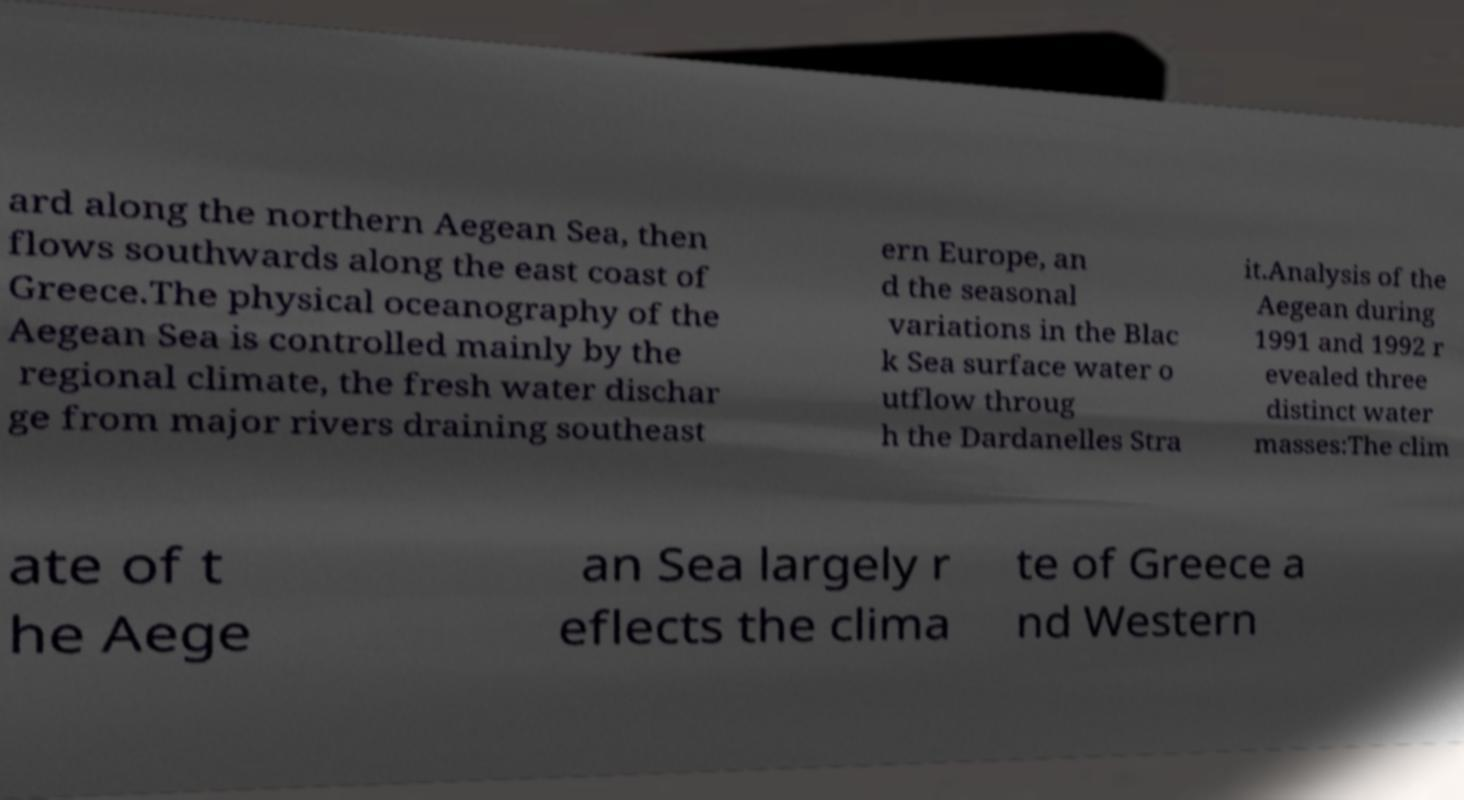There's text embedded in this image that I need extracted. Can you transcribe it verbatim? ard along the northern Aegean Sea, then flows southwards along the east coast of Greece.The physical oceanography of the Aegean Sea is controlled mainly by the regional climate, the fresh water dischar ge from major rivers draining southeast ern Europe, an d the seasonal variations in the Blac k Sea surface water o utflow throug h the Dardanelles Stra it.Analysis of the Aegean during 1991 and 1992 r evealed three distinct water masses:The clim ate of t he Aege an Sea largely r eflects the clima te of Greece a nd Western 